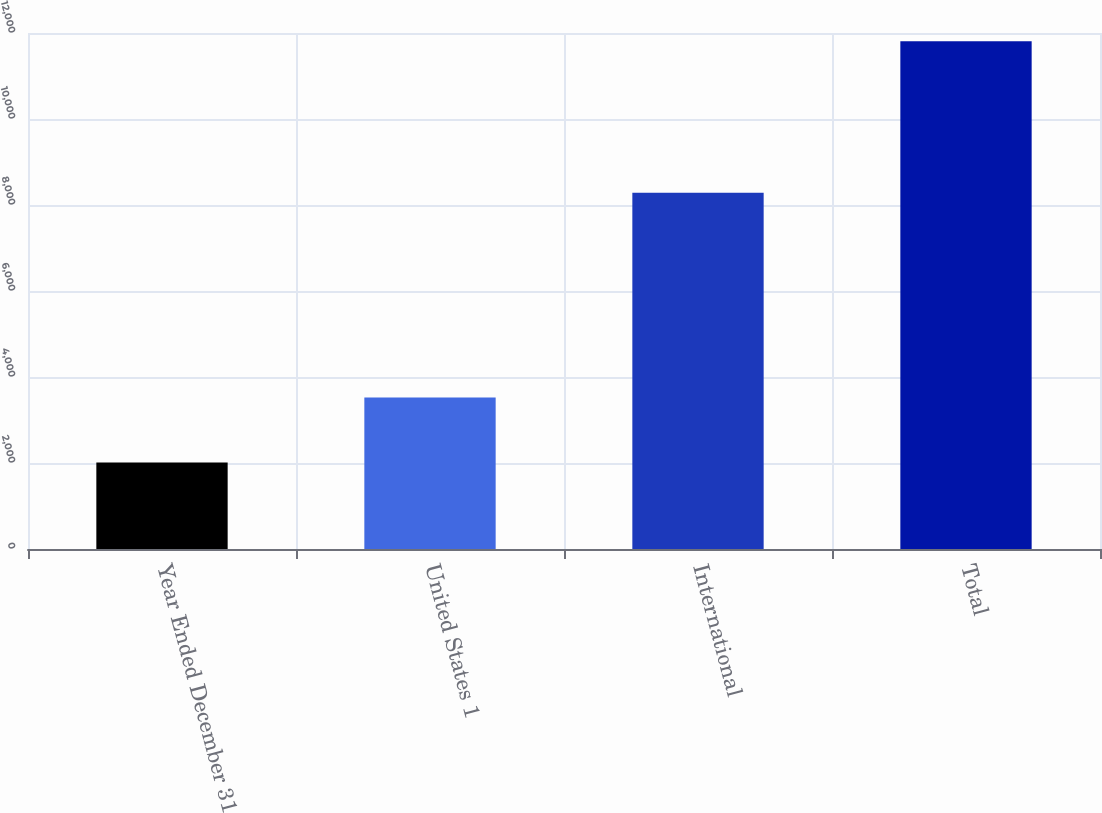<chart> <loc_0><loc_0><loc_500><loc_500><bar_chart><fcel>Year Ended December 31<fcel>United States 1<fcel>International<fcel>Total<nl><fcel>2012<fcel>3526<fcel>8283<fcel>11809<nl></chart> 